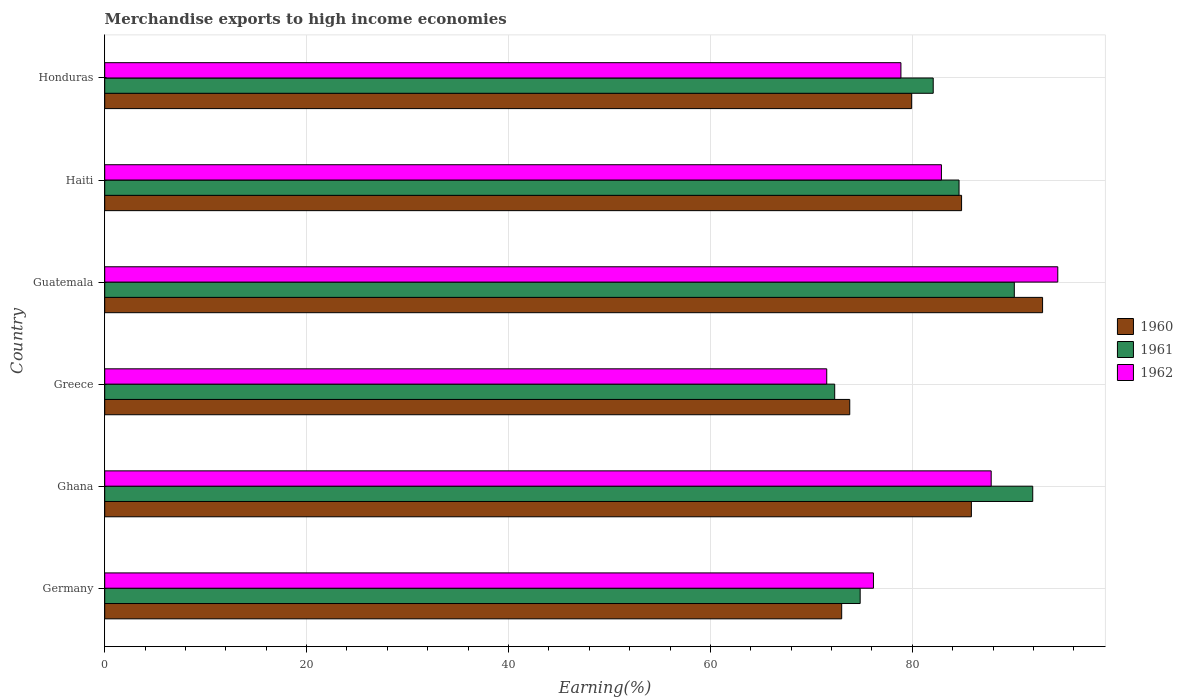Are the number of bars on each tick of the Y-axis equal?
Offer a terse response. Yes. How many bars are there on the 1st tick from the top?
Your response must be concise. 3. In how many cases, is the number of bars for a given country not equal to the number of legend labels?
Offer a very short reply. 0. What is the percentage of amount earned from merchandise exports in 1961 in Haiti?
Provide a succinct answer. 84.63. Across all countries, what is the maximum percentage of amount earned from merchandise exports in 1962?
Your answer should be compact. 94.41. Across all countries, what is the minimum percentage of amount earned from merchandise exports in 1962?
Provide a succinct answer. 71.53. In which country was the percentage of amount earned from merchandise exports in 1962 maximum?
Provide a succinct answer. Guatemala. What is the total percentage of amount earned from merchandise exports in 1961 in the graph?
Offer a very short reply. 495.9. What is the difference between the percentage of amount earned from merchandise exports in 1961 in Ghana and that in Honduras?
Make the answer very short. 9.86. What is the difference between the percentage of amount earned from merchandise exports in 1960 in Greece and the percentage of amount earned from merchandise exports in 1961 in Ghana?
Make the answer very short. -18.13. What is the average percentage of amount earned from merchandise exports in 1962 per country?
Provide a short and direct response. 81.95. What is the difference between the percentage of amount earned from merchandise exports in 1961 and percentage of amount earned from merchandise exports in 1960 in Ghana?
Keep it short and to the point. 6.08. In how many countries, is the percentage of amount earned from merchandise exports in 1962 greater than 52 %?
Offer a terse response. 6. What is the ratio of the percentage of amount earned from merchandise exports in 1962 in Greece to that in Honduras?
Make the answer very short. 0.91. Is the difference between the percentage of amount earned from merchandise exports in 1961 in Greece and Haiti greater than the difference between the percentage of amount earned from merchandise exports in 1960 in Greece and Haiti?
Make the answer very short. No. What is the difference between the highest and the second highest percentage of amount earned from merchandise exports in 1960?
Your answer should be very brief. 7.05. What is the difference between the highest and the lowest percentage of amount earned from merchandise exports in 1962?
Make the answer very short. 22.89. In how many countries, is the percentage of amount earned from merchandise exports in 1962 greater than the average percentage of amount earned from merchandise exports in 1962 taken over all countries?
Provide a short and direct response. 3. What does the 1st bar from the top in Greece represents?
Your answer should be very brief. 1962. What does the 1st bar from the bottom in Ghana represents?
Your answer should be compact. 1960. Is it the case that in every country, the sum of the percentage of amount earned from merchandise exports in 1960 and percentage of amount earned from merchandise exports in 1961 is greater than the percentage of amount earned from merchandise exports in 1962?
Offer a very short reply. Yes. How many countries are there in the graph?
Ensure brevity in your answer.  6. What is the difference between two consecutive major ticks on the X-axis?
Ensure brevity in your answer.  20. Where does the legend appear in the graph?
Your answer should be compact. Center right. How many legend labels are there?
Your answer should be compact. 3. How are the legend labels stacked?
Your response must be concise. Vertical. What is the title of the graph?
Ensure brevity in your answer.  Merchandise exports to high income economies. Does "1975" appear as one of the legend labels in the graph?
Make the answer very short. No. What is the label or title of the X-axis?
Provide a short and direct response. Earning(%). What is the Earning(%) in 1960 in Germany?
Keep it short and to the point. 73.01. What is the Earning(%) of 1961 in Germany?
Make the answer very short. 74.84. What is the Earning(%) of 1962 in Germany?
Make the answer very short. 76.15. What is the Earning(%) in 1960 in Ghana?
Offer a terse response. 85.85. What is the Earning(%) of 1961 in Ghana?
Give a very brief answer. 91.93. What is the Earning(%) of 1962 in Ghana?
Your answer should be very brief. 87.82. What is the Earning(%) in 1960 in Greece?
Offer a very short reply. 73.81. What is the Earning(%) in 1961 in Greece?
Provide a succinct answer. 72.31. What is the Earning(%) in 1962 in Greece?
Offer a very short reply. 71.53. What is the Earning(%) of 1960 in Guatemala?
Keep it short and to the point. 92.91. What is the Earning(%) in 1961 in Guatemala?
Give a very brief answer. 90.11. What is the Earning(%) in 1962 in Guatemala?
Offer a very short reply. 94.41. What is the Earning(%) of 1960 in Haiti?
Offer a terse response. 84.88. What is the Earning(%) in 1961 in Haiti?
Your answer should be very brief. 84.63. What is the Earning(%) of 1962 in Haiti?
Offer a terse response. 82.89. What is the Earning(%) of 1960 in Honduras?
Your answer should be compact. 79.94. What is the Earning(%) of 1961 in Honduras?
Your response must be concise. 82.07. What is the Earning(%) in 1962 in Honduras?
Provide a succinct answer. 78.88. Across all countries, what is the maximum Earning(%) of 1960?
Offer a terse response. 92.91. Across all countries, what is the maximum Earning(%) in 1961?
Your response must be concise. 91.93. Across all countries, what is the maximum Earning(%) in 1962?
Keep it short and to the point. 94.41. Across all countries, what is the minimum Earning(%) of 1960?
Your answer should be compact. 73.01. Across all countries, what is the minimum Earning(%) in 1961?
Ensure brevity in your answer.  72.31. Across all countries, what is the minimum Earning(%) in 1962?
Offer a very short reply. 71.53. What is the total Earning(%) in 1960 in the graph?
Keep it short and to the point. 490.4. What is the total Earning(%) in 1961 in the graph?
Offer a terse response. 495.9. What is the total Earning(%) in 1962 in the graph?
Your response must be concise. 491.67. What is the difference between the Earning(%) in 1960 in Germany and that in Ghana?
Make the answer very short. -12.85. What is the difference between the Earning(%) in 1961 in Germany and that in Ghana?
Provide a short and direct response. -17.09. What is the difference between the Earning(%) of 1962 in Germany and that in Ghana?
Ensure brevity in your answer.  -11.66. What is the difference between the Earning(%) in 1960 in Germany and that in Greece?
Offer a very short reply. -0.8. What is the difference between the Earning(%) of 1961 in Germany and that in Greece?
Offer a terse response. 2.52. What is the difference between the Earning(%) in 1962 in Germany and that in Greece?
Your answer should be very brief. 4.63. What is the difference between the Earning(%) in 1960 in Germany and that in Guatemala?
Offer a terse response. -19.9. What is the difference between the Earning(%) in 1961 in Germany and that in Guatemala?
Provide a short and direct response. -15.27. What is the difference between the Earning(%) of 1962 in Germany and that in Guatemala?
Provide a short and direct response. -18.26. What is the difference between the Earning(%) in 1960 in Germany and that in Haiti?
Give a very brief answer. -11.88. What is the difference between the Earning(%) of 1961 in Germany and that in Haiti?
Ensure brevity in your answer.  -9.8. What is the difference between the Earning(%) in 1962 in Germany and that in Haiti?
Provide a short and direct response. -6.73. What is the difference between the Earning(%) in 1960 in Germany and that in Honduras?
Your response must be concise. -6.93. What is the difference between the Earning(%) in 1961 in Germany and that in Honduras?
Provide a succinct answer. -7.24. What is the difference between the Earning(%) of 1962 in Germany and that in Honduras?
Offer a terse response. -2.72. What is the difference between the Earning(%) of 1960 in Ghana and that in Greece?
Keep it short and to the point. 12.05. What is the difference between the Earning(%) in 1961 in Ghana and that in Greece?
Keep it short and to the point. 19.62. What is the difference between the Earning(%) in 1962 in Ghana and that in Greece?
Your answer should be compact. 16.29. What is the difference between the Earning(%) of 1960 in Ghana and that in Guatemala?
Offer a very short reply. -7.05. What is the difference between the Earning(%) of 1961 in Ghana and that in Guatemala?
Your answer should be very brief. 1.82. What is the difference between the Earning(%) of 1962 in Ghana and that in Guatemala?
Provide a succinct answer. -6.6. What is the difference between the Earning(%) in 1960 in Ghana and that in Haiti?
Offer a very short reply. 0.97. What is the difference between the Earning(%) in 1961 in Ghana and that in Haiti?
Offer a very short reply. 7.3. What is the difference between the Earning(%) of 1962 in Ghana and that in Haiti?
Offer a very short reply. 4.93. What is the difference between the Earning(%) in 1960 in Ghana and that in Honduras?
Give a very brief answer. 5.92. What is the difference between the Earning(%) of 1961 in Ghana and that in Honduras?
Your answer should be very brief. 9.86. What is the difference between the Earning(%) of 1962 in Ghana and that in Honduras?
Your answer should be very brief. 8.94. What is the difference between the Earning(%) in 1960 in Greece and that in Guatemala?
Provide a short and direct response. -19.1. What is the difference between the Earning(%) in 1961 in Greece and that in Guatemala?
Give a very brief answer. -17.79. What is the difference between the Earning(%) of 1962 in Greece and that in Guatemala?
Your answer should be very brief. -22.89. What is the difference between the Earning(%) in 1960 in Greece and that in Haiti?
Provide a succinct answer. -11.08. What is the difference between the Earning(%) in 1961 in Greece and that in Haiti?
Offer a very short reply. -12.32. What is the difference between the Earning(%) in 1962 in Greece and that in Haiti?
Your answer should be compact. -11.36. What is the difference between the Earning(%) of 1960 in Greece and that in Honduras?
Give a very brief answer. -6.13. What is the difference between the Earning(%) of 1961 in Greece and that in Honduras?
Your response must be concise. -9.76. What is the difference between the Earning(%) of 1962 in Greece and that in Honduras?
Your answer should be compact. -7.35. What is the difference between the Earning(%) of 1960 in Guatemala and that in Haiti?
Make the answer very short. 8.02. What is the difference between the Earning(%) in 1961 in Guatemala and that in Haiti?
Provide a succinct answer. 5.48. What is the difference between the Earning(%) of 1962 in Guatemala and that in Haiti?
Ensure brevity in your answer.  11.53. What is the difference between the Earning(%) in 1960 in Guatemala and that in Honduras?
Ensure brevity in your answer.  12.97. What is the difference between the Earning(%) of 1961 in Guatemala and that in Honduras?
Offer a very short reply. 8.03. What is the difference between the Earning(%) of 1962 in Guatemala and that in Honduras?
Give a very brief answer. 15.54. What is the difference between the Earning(%) in 1960 in Haiti and that in Honduras?
Keep it short and to the point. 4.95. What is the difference between the Earning(%) of 1961 in Haiti and that in Honduras?
Make the answer very short. 2.56. What is the difference between the Earning(%) of 1962 in Haiti and that in Honduras?
Make the answer very short. 4.01. What is the difference between the Earning(%) of 1960 in Germany and the Earning(%) of 1961 in Ghana?
Your answer should be compact. -18.93. What is the difference between the Earning(%) in 1960 in Germany and the Earning(%) in 1962 in Ghana?
Give a very brief answer. -14.81. What is the difference between the Earning(%) in 1961 in Germany and the Earning(%) in 1962 in Ghana?
Give a very brief answer. -12.98. What is the difference between the Earning(%) in 1960 in Germany and the Earning(%) in 1961 in Greece?
Provide a succinct answer. 0.69. What is the difference between the Earning(%) of 1960 in Germany and the Earning(%) of 1962 in Greece?
Offer a very short reply. 1.48. What is the difference between the Earning(%) in 1961 in Germany and the Earning(%) in 1962 in Greece?
Offer a very short reply. 3.31. What is the difference between the Earning(%) in 1960 in Germany and the Earning(%) in 1961 in Guatemala?
Your response must be concise. -17.1. What is the difference between the Earning(%) of 1960 in Germany and the Earning(%) of 1962 in Guatemala?
Your answer should be compact. -21.41. What is the difference between the Earning(%) in 1961 in Germany and the Earning(%) in 1962 in Guatemala?
Your answer should be very brief. -19.58. What is the difference between the Earning(%) in 1960 in Germany and the Earning(%) in 1961 in Haiti?
Provide a succinct answer. -11.63. What is the difference between the Earning(%) in 1960 in Germany and the Earning(%) in 1962 in Haiti?
Provide a succinct answer. -9.88. What is the difference between the Earning(%) in 1961 in Germany and the Earning(%) in 1962 in Haiti?
Give a very brief answer. -8.05. What is the difference between the Earning(%) of 1960 in Germany and the Earning(%) of 1961 in Honduras?
Provide a short and direct response. -9.07. What is the difference between the Earning(%) in 1960 in Germany and the Earning(%) in 1962 in Honduras?
Your answer should be very brief. -5.87. What is the difference between the Earning(%) in 1961 in Germany and the Earning(%) in 1962 in Honduras?
Give a very brief answer. -4.04. What is the difference between the Earning(%) in 1960 in Ghana and the Earning(%) in 1961 in Greece?
Ensure brevity in your answer.  13.54. What is the difference between the Earning(%) in 1960 in Ghana and the Earning(%) in 1962 in Greece?
Give a very brief answer. 14.33. What is the difference between the Earning(%) of 1961 in Ghana and the Earning(%) of 1962 in Greece?
Provide a short and direct response. 20.41. What is the difference between the Earning(%) in 1960 in Ghana and the Earning(%) in 1961 in Guatemala?
Your answer should be very brief. -4.25. What is the difference between the Earning(%) in 1960 in Ghana and the Earning(%) in 1962 in Guatemala?
Ensure brevity in your answer.  -8.56. What is the difference between the Earning(%) of 1961 in Ghana and the Earning(%) of 1962 in Guatemala?
Provide a short and direct response. -2.48. What is the difference between the Earning(%) of 1960 in Ghana and the Earning(%) of 1961 in Haiti?
Offer a terse response. 1.22. What is the difference between the Earning(%) of 1960 in Ghana and the Earning(%) of 1962 in Haiti?
Your answer should be compact. 2.97. What is the difference between the Earning(%) in 1961 in Ghana and the Earning(%) in 1962 in Haiti?
Make the answer very short. 9.05. What is the difference between the Earning(%) in 1960 in Ghana and the Earning(%) in 1961 in Honduras?
Your response must be concise. 3.78. What is the difference between the Earning(%) of 1960 in Ghana and the Earning(%) of 1962 in Honduras?
Offer a terse response. 6.98. What is the difference between the Earning(%) in 1961 in Ghana and the Earning(%) in 1962 in Honduras?
Offer a very short reply. 13.06. What is the difference between the Earning(%) of 1960 in Greece and the Earning(%) of 1961 in Guatemala?
Offer a very short reply. -16.3. What is the difference between the Earning(%) in 1960 in Greece and the Earning(%) in 1962 in Guatemala?
Your answer should be compact. -20.61. What is the difference between the Earning(%) of 1961 in Greece and the Earning(%) of 1962 in Guatemala?
Provide a short and direct response. -22.1. What is the difference between the Earning(%) in 1960 in Greece and the Earning(%) in 1961 in Haiti?
Make the answer very short. -10.83. What is the difference between the Earning(%) of 1960 in Greece and the Earning(%) of 1962 in Haiti?
Your answer should be very brief. -9.08. What is the difference between the Earning(%) in 1961 in Greece and the Earning(%) in 1962 in Haiti?
Offer a terse response. -10.57. What is the difference between the Earning(%) of 1960 in Greece and the Earning(%) of 1961 in Honduras?
Offer a terse response. -8.27. What is the difference between the Earning(%) in 1960 in Greece and the Earning(%) in 1962 in Honduras?
Provide a succinct answer. -5.07. What is the difference between the Earning(%) of 1961 in Greece and the Earning(%) of 1962 in Honduras?
Offer a very short reply. -6.56. What is the difference between the Earning(%) of 1960 in Guatemala and the Earning(%) of 1961 in Haiti?
Your answer should be very brief. 8.27. What is the difference between the Earning(%) in 1960 in Guatemala and the Earning(%) in 1962 in Haiti?
Your answer should be very brief. 10.02. What is the difference between the Earning(%) in 1961 in Guatemala and the Earning(%) in 1962 in Haiti?
Make the answer very short. 7.22. What is the difference between the Earning(%) in 1960 in Guatemala and the Earning(%) in 1961 in Honduras?
Provide a succinct answer. 10.83. What is the difference between the Earning(%) of 1960 in Guatemala and the Earning(%) of 1962 in Honduras?
Offer a very short reply. 14.03. What is the difference between the Earning(%) in 1961 in Guatemala and the Earning(%) in 1962 in Honduras?
Give a very brief answer. 11.23. What is the difference between the Earning(%) of 1960 in Haiti and the Earning(%) of 1961 in Honduras?
Keep it short and to the point. 2.81. What is the difference between the Earning(%) in 1960 in Haiti and the Earning(%) in 1962 in Honduras?
Offer a very short reply. 6.01. What is the difference between the Earning(%) in 1961 in Haiti and the Earning(%) in 1962 in Honduras?
Your answer should be very brief. 5.76. What is the average Earning(%) of 1960 per country?
Your response must be concise. 81.73. What is the average Earning(%) in 1961 per country?
Provide a short and direct response. 82.65. What is the average Earning(%) of 1962 per country?
Keep it short and to the point. 81.95. What is the difference between the Earning(%) of 1960 and Earning(%) of 1961 in Germany?
Your response must be concise. -1.83. What is the difference between the Earning(%) in 1960 and Earning(%) in 1962 in Germany?
Offer a terse response. -3.15. What is the difference between the Earning(%) of 1961 and Earning(%) of 1962 in Germany?
Your response must be concise. -1.32. What is the difference between the Earning(%) in 1960 and Earning(%) in 1961 in Ghana?
Your response must be concise. -6.08. What is the difference between the Earning(%) in 1960 and Earning(%) in 1962 in Ghana?
Keep it short and to the point. -1.96. What is the difference between the Earning(%) in 1961 and Earning(%) in 1962 in Ghana?
Provide a succinct answer. 4.12. What is the difference between the Earning(%) in 1960 and Earning(%) in 1961 in Greece?
Your answer should be very brief. 1.49. What is the difference between the Earning(%) of 1960 and Earning(%) of 1962 in Greece?
Your response must be concise. 2.28. What is the difference between the Earning(%) in 1961 and Earning(%) in 1962 in Greece?
Provide a succinct answer. 0.79. What is the difference between the Earning(%) of 1960 and Earning(%) of 1961 in Guatemala?
Give a very brief answer. 2.8. What is the difference between the Earning(%) in 1960 and Earning(%) in 1962 in Guatemala?
Provide a succinct answer. -1.51. What is the difference between the Earning(%) in 1961 and Earning(%) in 1962 in Guatemala?
Keep it short and to the point. -4.3. What is the difference between the Earning(%) in 1960 and Earning(%) in 1961 in Haiti?
Your answer should be very brief. 0.25. What is the difference between the Earning(%) in 1960 and Earning(%) in 1962 in Haiti?
Provide a succinct answer. 2. What is the difference between the Earning(%) in 1961 and Earning(%) in 1962 in Haiti?
Offer a terse response. 1.75. What is the difference between the Earning(%) of 1960 and Earning(%) of 1961 in Honduras?
Make the answer very short. -2.14. What is the difference between the Earning(%) of 1960 and Earning(%) of 1962 in Honduras?
Keep it short and to the point. 1.06. What is the difference between the Earning(%) of 1961 and Earning(%) of 1962 in Honduras?
Make the answer very short. 3.2. What is the ratio of the Earning(%) in 1960 in Germany to that in Ghana?
Your response must be concise. 0.85. What is the ratio of the Earning(%) in 1961 in Germany to that in Ghana?
Keep it short and to the point. 0.81. What is the ratio of the Earning(%) in 1962 in Germany to that in Ghana?
Make the answer very short. 0.87. What is the ratio of the Earning(%) of 1960 in Germany to that in Greece?
Keep it short and to the point. 0.99. What is the ratio of the Earning(%) in 1961 in Germany to that in Greece?
Your answer should be very brief. 1.03. What is the ratio of the Earning(%) in 1962 in Germany to that in Greece?
Your answer should be compact. 1.06. What is the ratio of the Earning(%) in 1960 in Germany to that in Guatemala?
Provide a succinct answer. 0.79. What is the ratio of the Earning(%) in 1961 in Germany to that in Guatemala?
Offer a terse response. 0.83. What is the ratio of the Earning(%) of 1962 in Germany to that in Guatemala?
Give a very brief answer. 0.81. What is the ratio of the Earning(%) in 1960 in Germany to that in Haiti?
Offer a terse response. 0.86. What is the ratio of the Earning(%) of 1961 in Germany to that in Haiti?
Provide a succinct answer. 0.88. What is the ratio of the Earning(%) in 1962 in Germany to that in Haiti?
Provide a short and direct response. 0.92. What is the ratio of the Earning(%) in 1960 in Germany to that in Honduras?
Your answer should be very brief. 0.91. What is the ratio of the Earning(%) of 1961 in Germany to that in Honduras?
Your answer should be compact. 0.91. What is the ratio of the Earning(%) of 1962 in Germany to that in Honduras?
Offer a terse response. 0.97. What is the ratio of the Earning(%) in 1960 in Ghana to that in Greece?
Ensure brevity in your answer.  1.16. What is the ratio of the Earning(%) of 1961 in Ghana to that in Greece?
Your response must be concise. 1.27. What is the ratio of the Earning(%) of 1962 in Ghana to that in Greece?
Keep it short and to the point. 1.23. What is the ratio of the Earning(%) in 1960 in Ghana to that in Guatemala?
Give a very brief answer. 0.92. What is the ratio of the Earning(%) in 1961 in Ghana to that in Guatemala?
Your answer should be very brief. 1.02. What is the ratio of the Earning(%) of 1962 in Ghana to that in Guatemala?
Offer a very short reply. 0.93. What is the ratio of the Earning(%) in 1960 in Ghana to that in Haiti?
Give a very brief answer. 1.01. What is the ratio of the Earning(%) in 1961 in Ghana to that in Haiti?
Provide a short and direct response. 1.09. What is the ratio of the Earning(%) of 1962 in Ghana to that in Haiti?
Make the answer very short. 1.06. What is the ratio of the Earning(%) of 1960 in Ghana to that in Honduras?
Ensure brevity in your answer.  1.07. What is the ratio of the Earning(%) in 1961 in Ghana to that in Honduras?
Give a very brief answer. 1.12. What is the ratio of the Earning(%) of 1962 in Ghana to that in Honduras?
Give a very brief answer. 1.11. What is the ratio of the Earning(%) in 1960 in Greece to that in Guatemala?
Ensure brevity in your answer.  0.79. What is the ratio of the Earning(%) of 1961 in Greece to that in Guatemala?
Provide a short and direct response. 0.8. What is the ratio of the Earning(%) of 1962 in Greece to that in Guatemala?
Make the answer very short. 0.76. What is the ratio of the Earning(%) in 1960 in Greece to that in Haiti?
Provide a short and direct response. 0.87. What is the ratio of the Earning(%) in 1961 in Greece to that in Haiti?
Provide a short and direct response. 0.85. What is the ratio of the Earning(%) of 1962 in Greece to that in Haiti?
Offer a very short reply. 0.86. What is the ratio of the Earning(%) in 1960 in Greece to that in Honduras?
Give a very brief answer. 0.92. What is the ratio of the Earning(%) in 1961 in Greece to that in Honduras?
Your answer should be very brief. 0.88. What is the ratio of the Earning(%) in 1962 in Greece to that in Honduras?
Your answer should be compact. 0.91. What is the ratio of the Earning(%) in 1960 in Guatemala to that in Haiti?
Ensure brevity in your answer.  1.09. What is the ratio of the Earning(%) in 1961 in Guatemala to that in Haiti?
Offer a very short reply. 1.06. What is the ratio of the Earning(%) in 1962 in Guatemala to that in Haiti?
Ensure brevity in your answer.  1.14. What is the ratio of the Earning(%) in 1960 in Guatemala to that in Honduras?
Your answer should be very brief. 1.16. What is the ratio of the Earning(%) of 1961 in Guatemala to that in Honduras?
Provide a succinct answer. 1.1. What is the ratio of the Earning(%) of 1962 in Guatemala to that in Honduras?
Ensure brevity in your answer.  1.2. What is the ratio of the Earning(%) in 1960 in Haiti to that in Honduras?
Make the answer very short. 1.06. What is the ratio of the Earning(%) of 1961 in Haiti to that in Honduras?
Make the answer very short. 1.03. What is the ratio of the Earning(%) in 1962 in Haiti to that in Honduras?
Ensure brevity in your answer.  1.05. What is the difference between the highest and the second highest Earning(%) of 1960?
Your answer should be very brief. 7.05. What is the difference between the highest and the second highest Earning(%) of 1961?
Keep it short and to the point. 1.82. What is the difference between the highest and the second highest Earning(%) in 1962?
Your answer should be compact. 6.6. What is the difference between the highest and the lowest Earning(%) in 1960?
Make the answer very short. 19.9. What is the difference between the highest and the lowest Earning(%) in 1961?
Your response must be concise. 19.62. What is the difference between the highest and the lowest Earning(%) in 1962?
Ensure brevity in your answer.  22.89. 